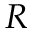<formula> <loc_0><loc_0><loc_500><loc_500>R</formula> 